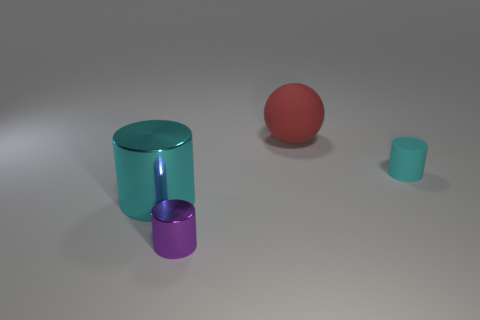How many other things are the same color as the big cylinder?
Offer a very short reply. 1. Does the tiny rubber thing have the same color as the large cylinder?
Keep it short and to the point. Yes. What is the material of the other cylinder that is the same color as the matte cylinder?
Ensure brevity in your answer.  Metal. Is the purple thing made of the same material as the big red sphere?
Keep it short and to the point. No. What shape is the small matte thing?
Give a very brief answer. Cylinder. There is a tiny thing on the left side of the tiny cyan rubber cylinder; what is its material?
Keep it short and to the point. Metal. Is there a tiny matte object of the same color as the big cylinder?
Keep it short and to the point. Yes. What shape is the object that is the same size as the matte cylinder?
Keep it short and to the point. Cylinder. The big thing that is on the left side of the tiny metallic cylinder is what color?
Provide a short and direct response. Cyan. Are there any tiny cylinders in front of the thing that is to the left of the purple shiny thing?
Provide a succinct answer. Yes. 